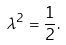<formula> <loc_0><loc_0><loc_500><loc_500>\lambda ^ { 2 } = \frac { 1 } { 2 } .</formula> 